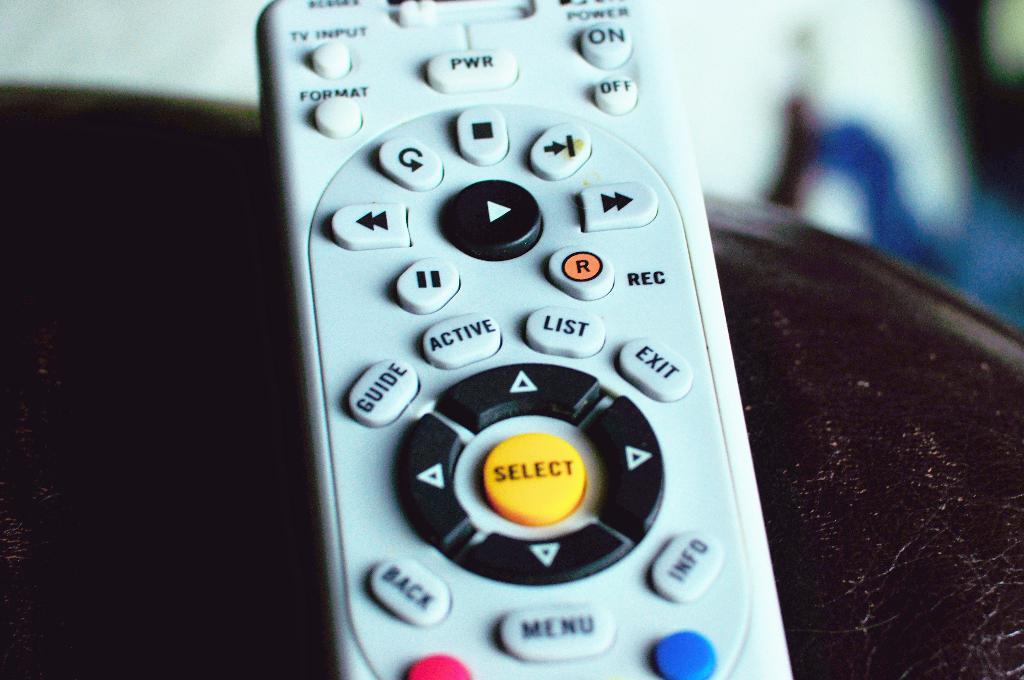Provide a one-sentence caption for the provided image. A remote control with a center select button between directional buttons. 